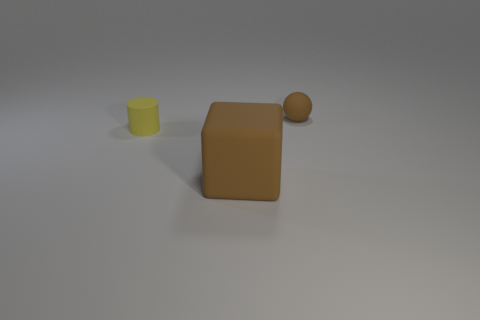Is there any other thing that has the same size as the matte block?
Provide a succinct answer. No. Is there any other thing that is the same shape as the large object?
Provide a succinct answer. No. Are there the same number of tiny things that are to the left of the big brown cube and small brown shiny cylinders?
Make the answer very short. No. There is a rubber object that is both right of the yellow matte cylinder and in front of the brown sphere; what size is it?
Offer a terse response. Large. The matte object that is behind the small matte object left of the small brown rubber thing is what color?
Offer a very short reply. Brown. What number of gray objects are matte spheres or blocks?
Your answer should be compact. 0. There is a thing that is both to the right of the tiny yellow matte thing and behind the matte block; what is its color?
Your answer should be very brief. Brown. What number of large objects are either purple rubber cylinders or matte objects?
Your answer should be very brief. 1. The small brown thing has what shape?
Your response must be concise. Sphere. What number of rubber things are either tiny yellow objects or yellow balls?
Keep it short and to the point. 1. 